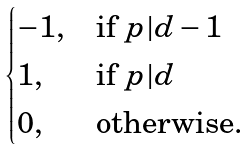<formula> <loc_0><loc_0><loc_500><loc_500>\begin{cases} - 1 , & \text {if } p | d - 1 \\ 1 , & \text {if } p | d \\ 0 , & \text {otherwise.} \end{cases}</formula> 